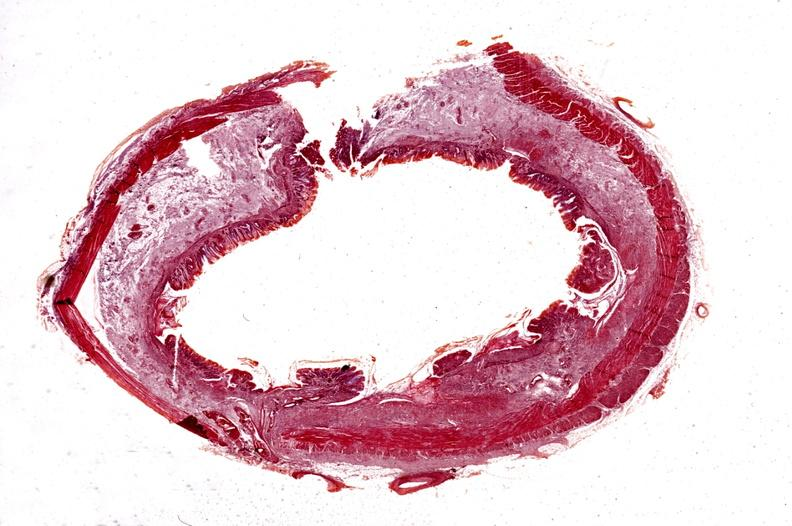what does this image show?
Answer the question using a single word or phrase. Colon 